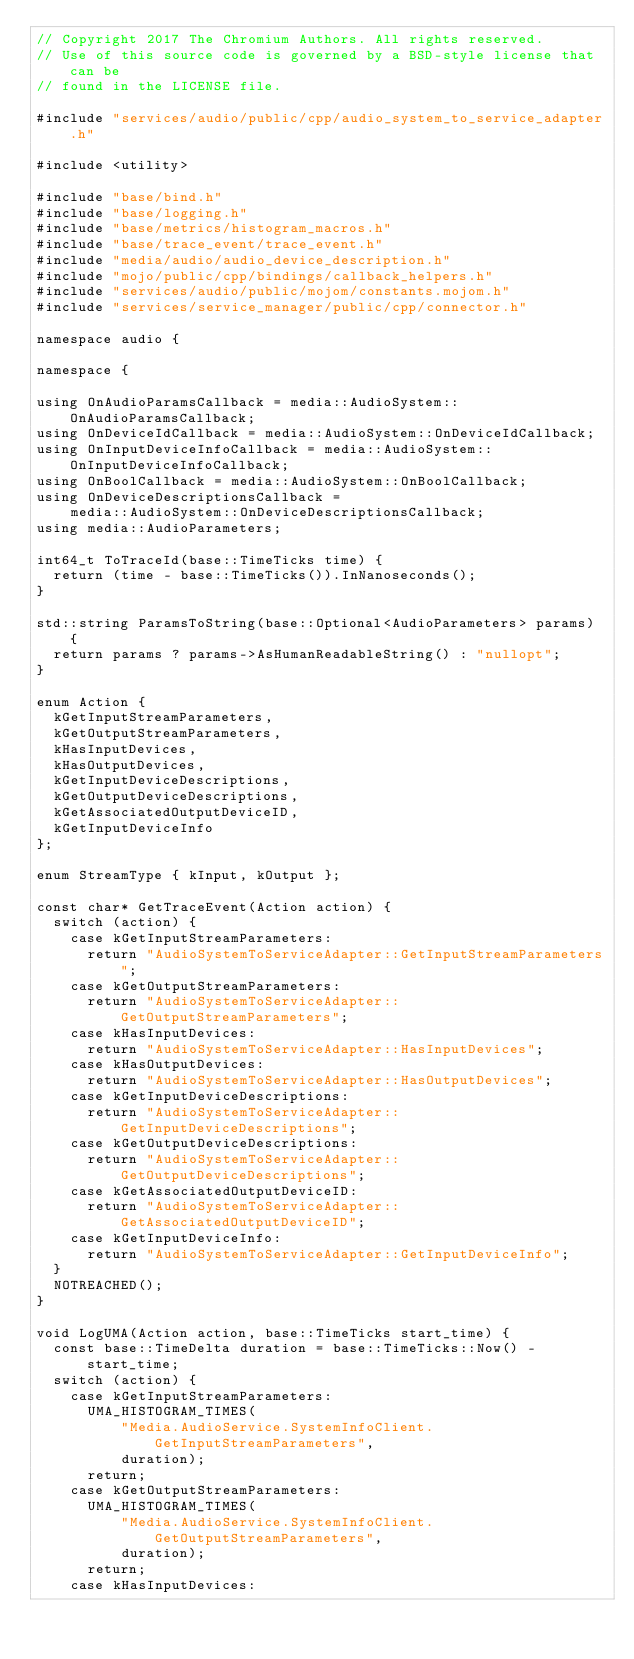Convert code to text. <code><loc_0><loc_0><loc_500><loc_500><_C++_>// Copyright 2017 The Chromium Authors. All rights reserved.
// Use of this source code is governed by a BSD-style license that can be
// found in the LICENSE file.

#include "services/audio/public/cpp/audio_system_to_service_adapter.h"

#include <utility>

#include "base/bind.h"
#include "base/logging.h"
#include "base/metrics/histogram_macros.h"
#include "base/trace_event/trace_event.h"
#include "media/audio/audio_device_description.h"
#include "mojo/public/cpp/bindings/callback_helpers.h"
#include "services/audio/public/mojom/constants.mojom.h"
#include "services/service_manager/public/cpp/connector.h"

namespace audio {

namespace {

using OnAudioParamsCallback = media::AudioSystem::OnAudioParamsCallback;
using OnDeviceIdCallback = media::AudioSystem::OnDeviceIdCallback;
using OnInputDeviceInfoCallback = media::AudioSystem::OnInputDeviceInfoCallback;
using OnBoolCallback = media::AudioSystem::OnBoolCallback;
using OnDeviceDescriptionsCallback =
    media::AudioSystem::OnDeviceDescriptionsCallback;
using media::AudioParameters;

int64_t ToTraceId(base::TimeTicks time) {
  return (time - base::TimeTicks()).InNanoseconds();
}

std::string ParamsToString(base::Optional<AudioParameters> params) {
  return params ? params->AsHumanReadableString() : "nullopt";
}

enum Action {
  kGetInputStreamParameters,
  kGetOutputStreamParameters,
  kHasInputDevices,
  kHasOutputDevices,
  kGetInputDeviceDescriptions,
  kGetOutputDeviceDescriptions,
  kGetAssociatedOutputDeviceID,
  kGetInputDeviceInfo
};

enum StreamType { kInput, kOutput };

const char* GetTraceEvent(Action action) {
  switch (action) {
    case kGetInputStreamParameters:
      return "AudioSystemToServiceAdapter::GetInputStreamParameters";
    case kGetOutputStreamParameters:
      return "AudioSystemToServiceAdapter::GetOutputStreamParameters";
    case kHasInputDevices:
      return "AudioSystemToServiceAdapter::HasInputDevices";
    case kHasOutputDevices:
      return "AudioSystemToServiceAdapter::HasOutputDevices";
    case kGetInputDeviceDescriptions:
      return "AudioSystemToServiceAdapter::GetInputDeviceDescriptions";
    case kGetOutputDeviceDescriptions:
      return "AudioSystemToServiceAdapter::GetOutputDeviceDescriptions";
    case kGetAssociatedOutputDeviceID:
      return "AudioSystemToServiceAdapter::GetAssociatedOutputDeviceID";
    case kGetInputDeviceInfo:
      return "AudioSystemToServiceAdapter::GetInputDeviceInfo";
  }
  NOTREACHED();
}

void LogUMA(Action action, base::TimeTicks start_time) {
  const base::TimeDelta duration = base::TimeTicks::Now() - start_time;
  switch (action) {
    case kGetInputStreamParameters:
      UMA_HISTOGRAM_TIMES(
          "Media.AudioService.SystemInfoClient.GetInputStreamParameters",
          duration);
      return;
    case kGetOutputStreamParameters:
      UMA_HISTOGRAM_TIMES(
          "Media.AudioService.SystemInfoClient.GetOutputStreamParameters",
          duration);
      return;
    case kHasInputDevices:</code> 